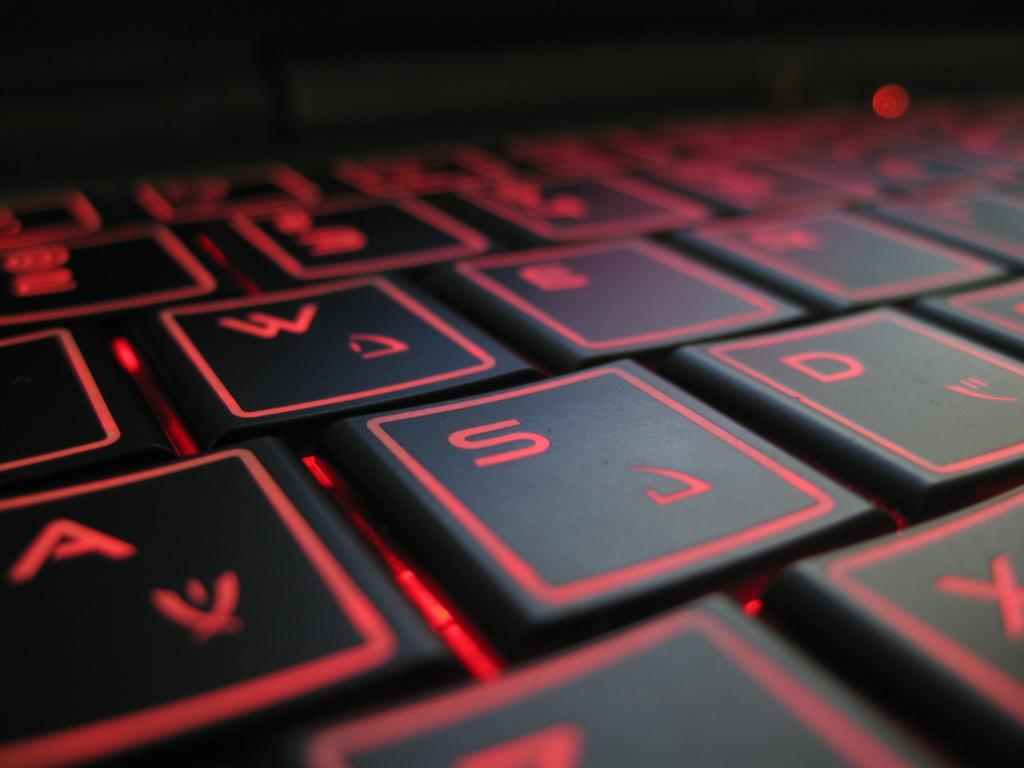<image>
Describe the image concisely. Black and red keyboard that has the letter S between the letters A and D. 